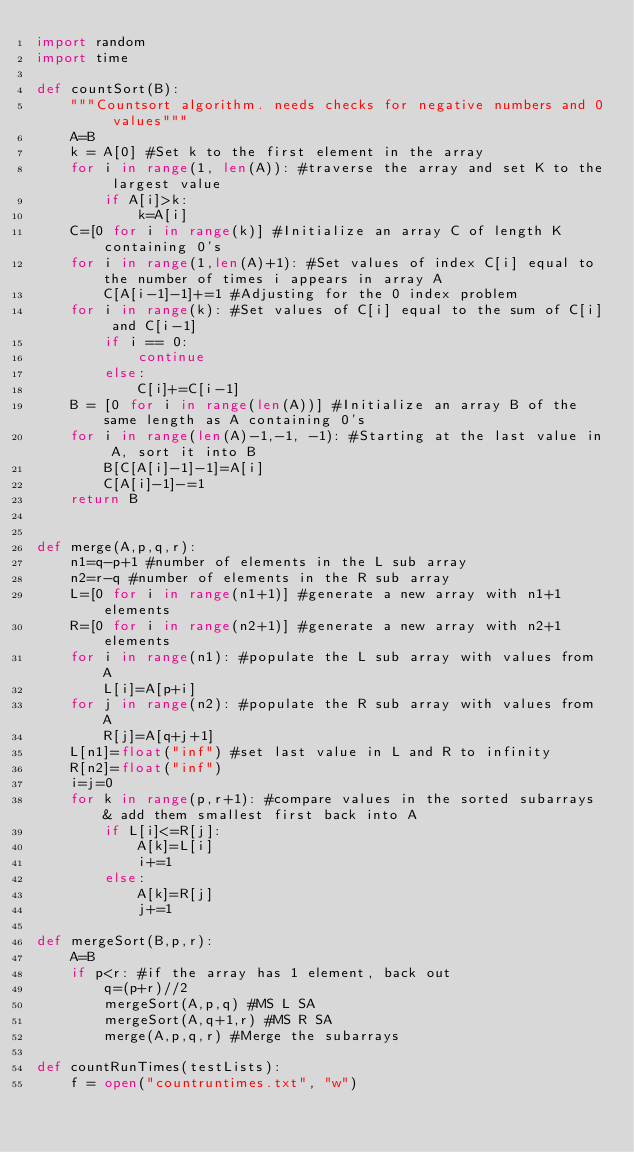Convert code to text. <code><loc_0><loc_0><loc_500><loc_500><_Python_>import random
import time

def countSort(B):
	"""Countsort algorithm. needs checks for negative numbers and 0 values"""
	A=B
	k = A[0] #Set k to the first element in the array
	for i in range(1, len(A)): #traverse the array and set K to the largest value
		if A[i]>k:
			k=A[i]
	C=[0 for i in range(k)] #Initialize an array C of length K containing 0's
	for i in range(1,len(A)+1): #Set values of index C[i] equal to the number of times i appears in array A
		C[A[i-1]-1]+=1 #Adjusting for the 0 index problem
	for i in range(k): #Set values of C[i] equal to the sum of C[i] and C[i-1] 
		if i == 0:
			continue
		else:
			C[i]+=C[i-1]
	B = [0 for i in range(len(A))] #Initialize an array B of the same length as A containing 0's
	for i in range(len(A)-1,-1, -1): #Starting at the last value in A, sort it into B
		B[C[A[i]-1]-1]=A[i]
		C[A[i]-1]-=1
	return B


def merge(A,p,q,r):
	n1=q-p+1 #number of elements in the L sub array
	n2=r-q #number of elements in the R sub array
	L=[0 for i in range(n1+1)] #generate a new array with n1+1 elements
	R=[0 for i in range(n2+1)] #generate a new array with n2+1 elements
	for i in range(n1): #populate the L sub array with values from A
		L[i]=A[p+i]
	for j in range(n2): #populate the R sub array with values from A
		R[j]=A[q+j+1]
	L[n1]=float("inf") #set last value in L and R to infinity
	R[n2]=float("inf")
	i=j=0
	for k in range(p,r+1): #compare values in the sorted subarrays & add them smallest first back into A
		if L[i]<=R[j]:
			A[k]=L[i]
			i+=1
		else:
			A[k]=R[j]
			j+=1

def mergeSort(B,p,r):
	A=B
	if p<r: #if the array has 1 element, back out
		q=(p+r)//2
		mergeSort(A,p,q) #MS L SA
		mergeSort(A,q+1,r) #MS R SA
		merge(A,p,q,r) #Merge the subarrays

def countRunTimes(testLists):
	f = open("countruntimes.txt", "w")</code> 